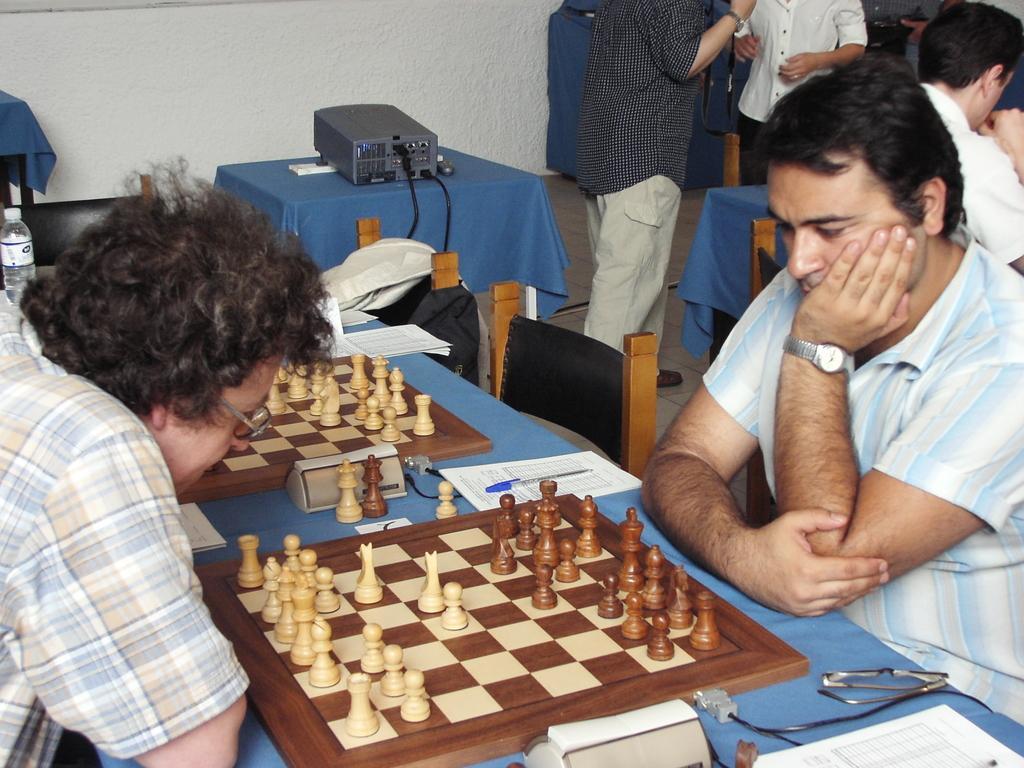Describe this image in one or two sentences. There are two men sitting in front of each other in their chairs. There is a table in between them on which a chess board was placed. Both of them were playing chess. In the background there are some people standing. Equipment is placed on the table. There is a wall here. 